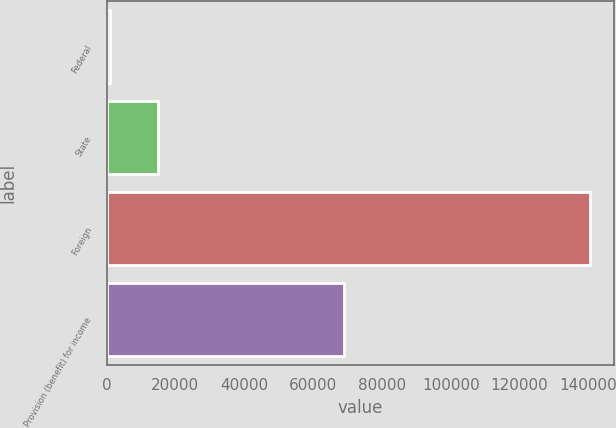Convert chart to OTSL. <chart><loc_0><loc_0><loc_500><loc_500><bar_chart><fcel>Federal<fcel>State<fcel>Foreign<fcel>Provision (benefit) for income<nl><fcel>1120<fcel>15051<fcel>140430<fcel>68975<nl></chart> 